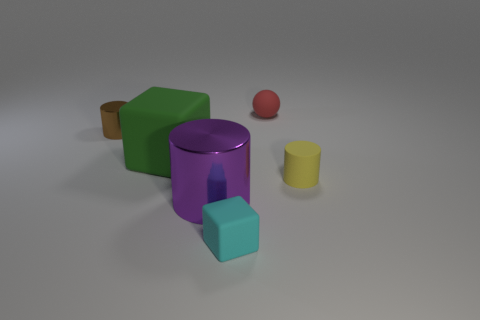Add 2 tiny red spheres. How many objects exist? 8 Subtract all tiny yellow rubber cylinders. How many cylinders are left? 2 Subtract all blue cylinders. How many cyan spheres are left? 0 Subtract all big matte balls. Subtract all metal things. How many objects are left? 4 Add 5 large cylinders. How many large cylinders are left? 6 Add 6 tiny blue cylinders. How many tiny blue cylinders exist? 6 Subtract all brown cylinders. How many cylinders are left? 2 Subtract 0 blue cylinders. How many objects are left? 6 Subtract all cubes. How many objects are left? 4 Subtract 1 blocks. How many blocks are left? 1 